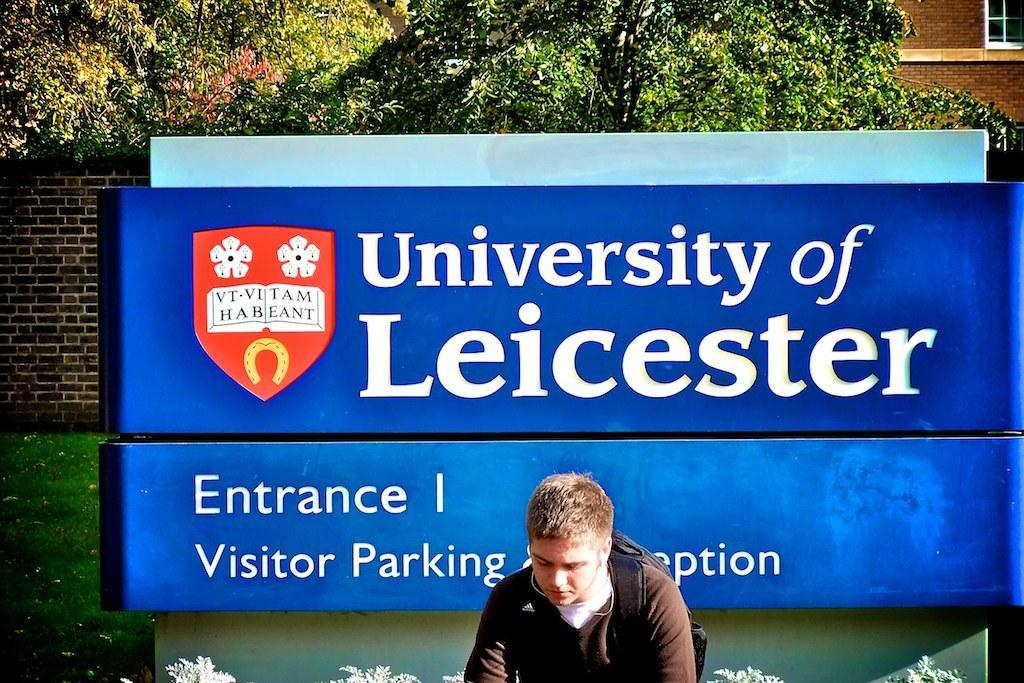<image>
Write a terse but informative summary of the picture. A person stands in front of a large University of Leicester sign. 